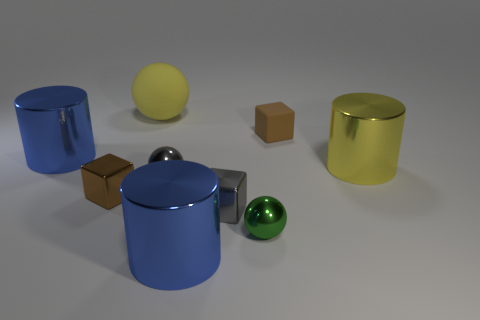Is the texture of the blue cylinders the same as that of the yellow sphere? No, the texture of the blue cylinders is different from that of the yellow sphere. The blue cylinders have a smooth, metallic sheen, while the yellow sphere has a subtle textured surface that reflects light in a less uniform manner. 